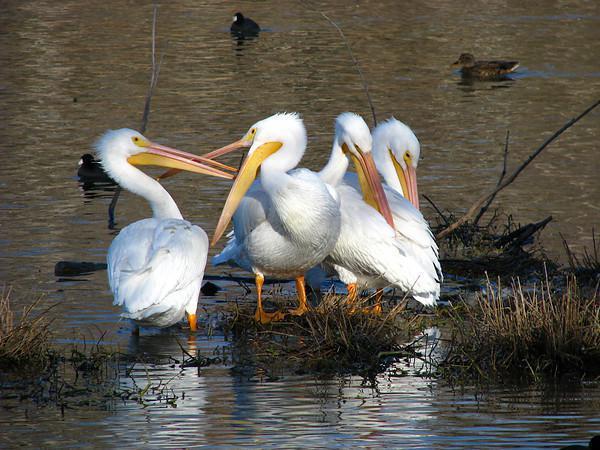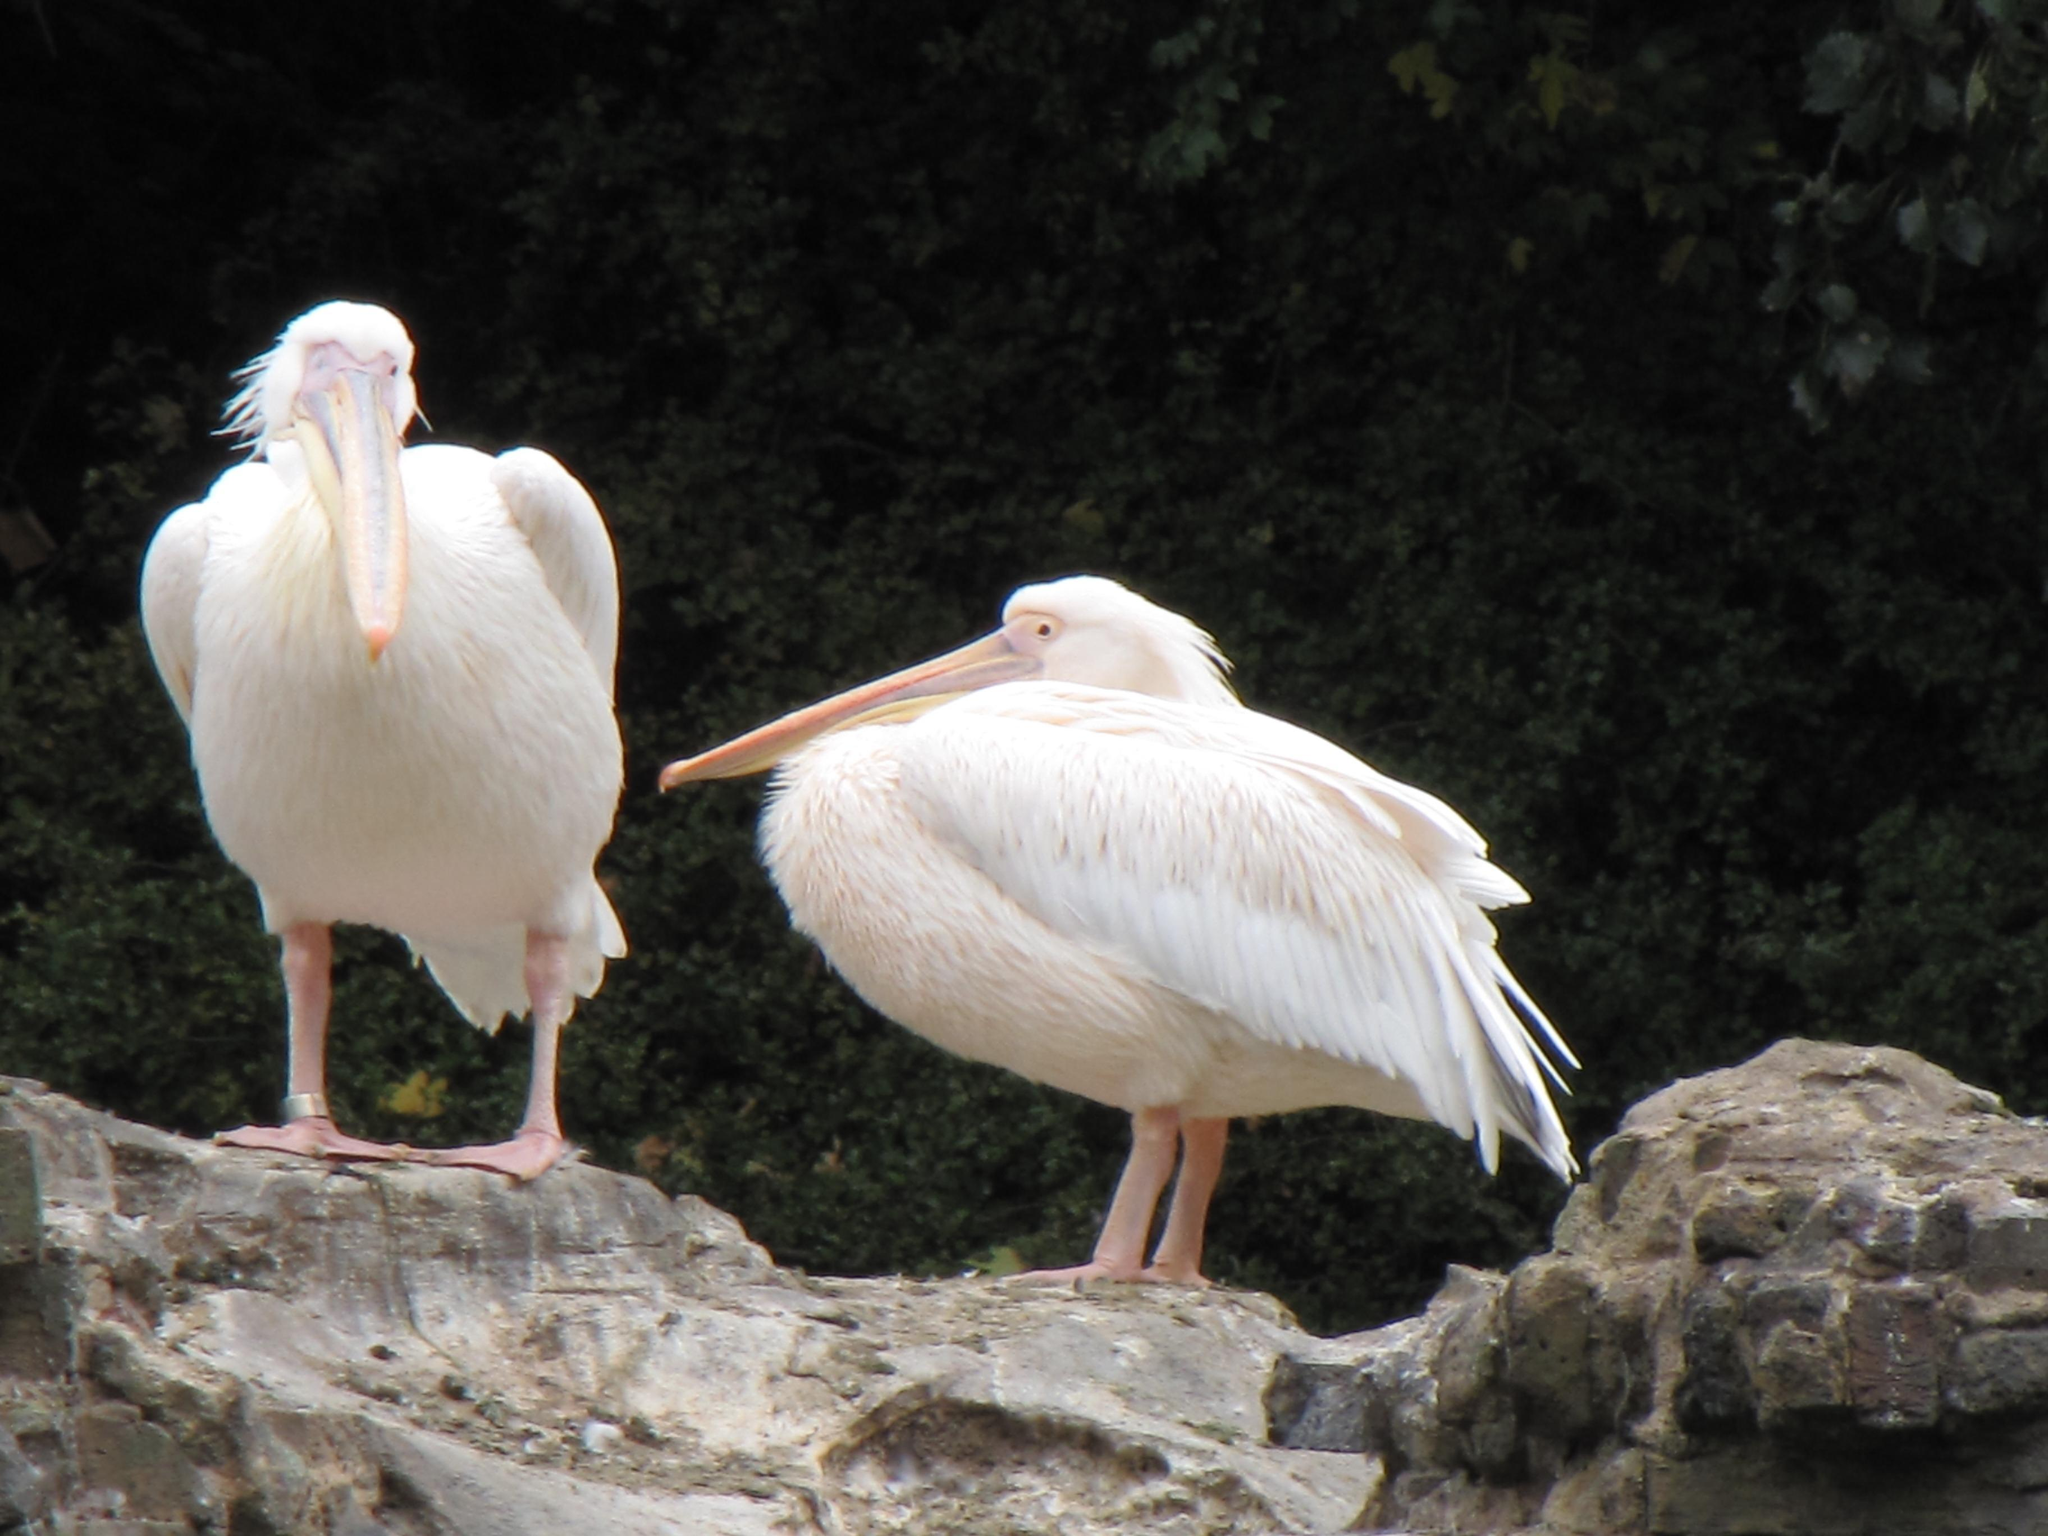The first image is the image on the left, the second image is the image on the right. For the images displayed, is the sentence "there are no more then two birds in the left pic" factually correct? Answer yes or no. No. The first image is the image on the left, the second image is the image on the right. For the images displayed, is the sentence "There are at least six pelicans." factually correct? Answer yes or no. Yes. 